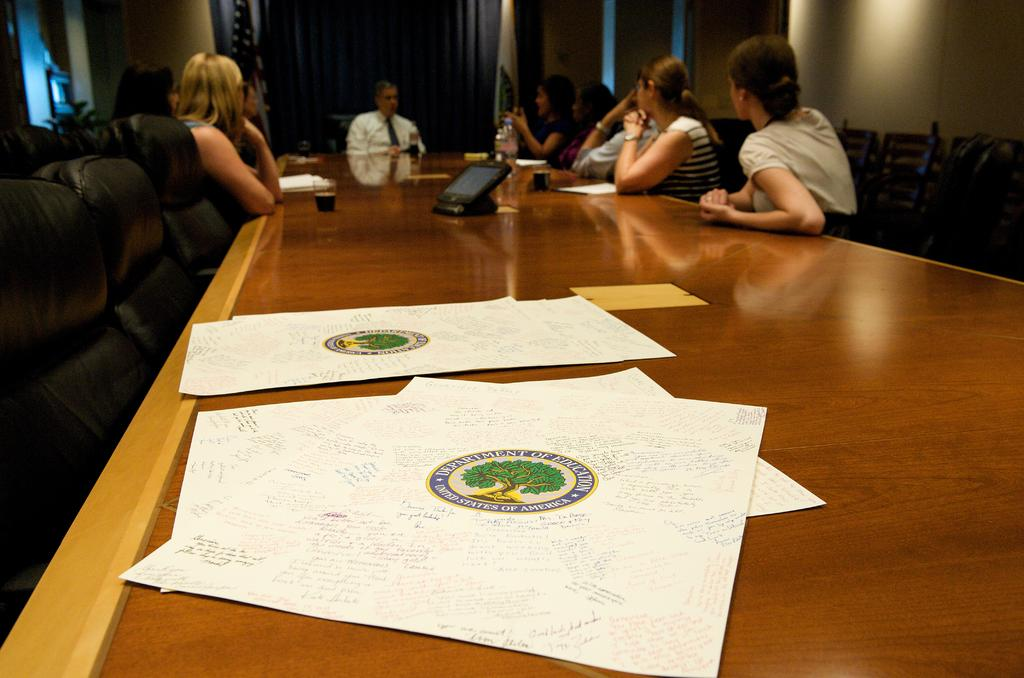How many people are in the image? There is a group of people in the image. What are the people doing in the image? The people are sitting in front of a table. What items can be seen on the table? There are papers, glasses, and a bottle on the table. What type of furniture is visible on the hill in the image? There is no furniture or hill present in the image. How does the brain of the person sitting at the table look like in the image? There is no brain visible in the image; it only shows a group of people sitting in front of a table with papers, glasses, and a bottle. 